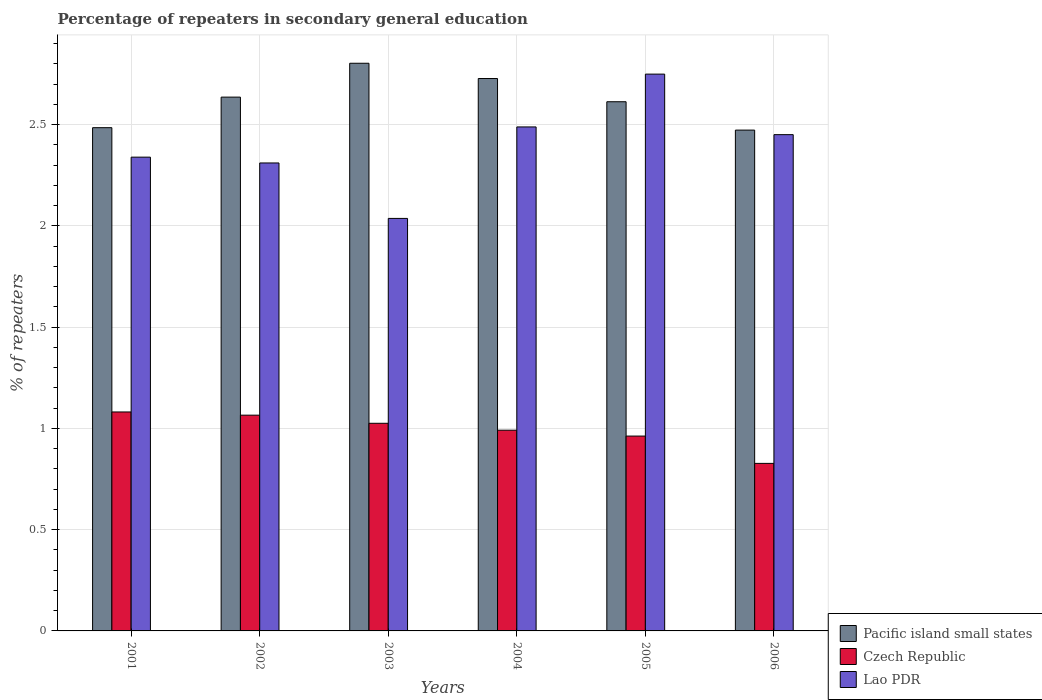Are the number of bars per tick equal to the number of legend labels?
Ensure brevity in your answer.  Yes. How many bars are there on the 3rd tick from the left?
Give a very brief answer. 3. What is the label of the 6th group of bars from the left?
Make the answer very short. 2006. In how many cases, is the number of bars for a given year not equal to the number of legend labels?
Ensure brevity in your answer.  0. What is the percentage of repeaters in secondary general education in Pacific island small states in 2003?
Give a very brief answer. 2.8. Across all years, what is the maximum percentage of repeaters in secondary general education in Lao PDR?
Offer a very short reply. 2.75. Across all years, what is the minimum percentage of repeaters in secondary general education in Lao PDR?
Offer a very short reply. 2.04. In which year was the percentage of repeaters in secondary general education in Lao PDR maximum?
Give a very brief answer. 2005. In which year was the percentage of repeaters in secondary general education in Pacific island small states minimum?
Your answer should be compact. 2006. What is the total percentage of repeaters in secondary general education in Lao PDR in the graph?
Ensure brevity in your answer.  14.37. What is the difference between the percentage of repeaters in secondary general education in Czech Republic in 2004 and that in 2006?
Keep it short and to the point. 0.16. What is the difference between the percentage of repeaters in secondary general education in Pacific island small states in 2005 and the percentage of repeaters in secondary general education in Lao PDR in 2006?
Give a very brief answer. 0.16. What is the average percentage of repeaters in secondary general education in Czech Republic per year?
Your answer should be compact. 0.99. In the year 2006, what is the difference between the percentage of repeaters in secondary general education in Lao PDR and percentage of repeaters in secondary general education in Pacific island small states?
Provide a succinct answer. -0.02. What is the ratio of the percentage of repeaters in secondary general education in Pacific island small states in 2004 to that in 2006?
Offer a very short reply. 1.1. Is the percentage of repeaters in secondary general education in Pacific island small states in 2003 less than that in 2005?
Offer a very short reply. No. Is the difference between the percentage of repeaters in secondary general education in Lao PDR in 2001 and 2003 greater than the difference between the percentage of repeaters in secondary general education in Pacific island small states in 2001 and 2003?
Your answer should be very brief. Yes. What is the difference between the highest and the second highest percentage of repeaters in secondary general education in Czech Republic?
Offer a terse response. 0.02. What is the difference between the highest and the lowest percentage of repeaters in secondary general education in Czech Republic?
Your answer should be compact. 0.25. What does the 3rd bar from the left in 2001 represents?
Your answer should be compact. Lao PDR. What does the 2nd bar from the right in 2003 represents?
Offer a terse response. Czech Republic. How many bars are there?
Offer a terse response. 18. Are the values on the major ticks of Y-axis written in scientific E-notation?
Your response must be concise. No. Does the graph contain any zero values?
Your answer should be very brief. No. Where does the legend appear in the graph?
Your answer should be very brief. Bottom right. How are the legend labels stacked?
Ensure brevity in your answer.  Vertical. What is the title of the graph?
Make the answer very short. Percentage of repeaters in secondary general education. Does "New Caledonia" appear as one of the legend labels in the graph?
Give a very brief answer. No. What is the label or title of the X-axis?
Your answer should be very brief. Years. What is the label or title of the Y-axis?
Your response must be concise. % of repeaters. What is the % of repeaters of Pacific island small states in 2001?
Provide a short and direct response. 2.48. What is the % of repeaters of Czech Republic in 2001?
Make the answer very short. 1.08. What is the % of repeaters in Lao PDR in 2001?
Ensure brevity in your answer.  2.34. What is the % of repeaters in Pacific island small states in 2002?
Offer a very short reply. 2.64. What is the % of repeaters of Czech Republic in 2002?
Provide a succinct answer. 1.07. What is the % of repeaters of Lao PDR in 2002?
Make the answer very short. 2.31. What is the % of repeaters of Pacific island small states in 2003?
Give a very brief answer. 2.8. What is the % of repeaters in Czech Republic in 2003?
Your response must be concise. 1.03. What is the % of repeaters of Lao PDR in 2003?
Provide a short and direct response. 2.04. What is the % of repeaters in Pacific island small states in 2004?
Your response must be concise. 2.73. What is the % of repeaters in Czech Republic in 2004?
Offer a very short reply. 0.99. What is the % of repeaters in Lao PDR in 2004?
Give a very brief answer. 2.49. What is the % of repeaters of Pacific island small states in 2005?
Your response must be concise. 2.61. What is the % of repeaters of Czech Republic in 2005?
Your response must be concise. 0.96. What is the % of repeaters in Lao PDR in 2005?
Provide a succinct answer. 2.75. What is the % of repeaters in Pacific island small states in 2006?
Make the answer very short. 2.47. What is the % of repeaters in Czech Republic in 2006?
Provide a succinct answer. 0.83. What is the % of repeaters in Lao PDR in 2006?
Provide a short and direct response. 2.45. Across all years, what is the maximum % of repeaters of Pacific island small states?
Provide a short and direct response. 2.8. Across all years, what is the maximum % of repeaters in Czech Republic?
Offer a terse response. 1.08. Across all years, what is the maximum % of repeaters of Lao PDR?
Keep it short and to the point. 2.75. Across all years, what is the minimum % of repeaters of Pacific island small states?
Ensure brevity in your answer.  2.47. Across all years, what is the minimum % of repeaters of Czech Republic?
Keep it short and to the point. 0.83. Across all years, what is the minimum % of repeaters of Lao PDR?
Ensure brevity in your answer.  2.04. What is the total % of repeaters of Pacific island small states in the graph?
Your answer should be compact. 15.74. What is the total % of repeaters in Czech Republic in the graph?
Provide a short and direct response. 5.95. What is the total % of repeaters in Lao PDR in the graph?
Keep it short and to the point. 14.37. What is the difference between the % of repeaters in Pacific island small states in 2001 and that in 2002?
Your answer should be compact. -0.15. What is the difference between the % of repeaters in Czech Republic in 2001 and that in 2002?
Offer a very short reply. 0.02. What is the difference between the % of repeaters in Lao PDR in 2001 and that in 2002?
Provide a succinct answer. 0.03. What is the difference between the % of repeaters in Pacific island small states in 2001 and that in 2003?
Provide a short and direct response. -0.32. What is the difference between the % of repeaters of Czech Republic in 2001 and that in 2003?
Keep it short and to the point. 0.06. What is the difference between the % of repeaters in Lao PDR in 2001 and that in 2003?
Provide a short and direct response. 0.3. What is the difference between the % of repeaters of Pacific island small states in 2001 and that in 2004?
Offer a terse response. -0.24. What is the difference between the % of repeaters of Czech Republic in 2001 and that in 2004?
Your answer should be very brief. 0.09. What is the difference between the % of repeaters in Lao PDR in 2001 and that in 2004?
Your answer should be compact. -0.15. What is the difference between the % of repeaters of Pacific island small states in 2001 and that in 2005?
Give a very brief answer. -0.13. What is the difference between the % of repeaters in Czech Republic in 2001 and that in 2005?
Keep it short and to the point. 0.12. What is the difference between the % of repeaters of Lao PDR in 2001 and that in 2005?
Give a very brief answer. -0.41. What is the difference between the % of repeaters in Pacific island small states in 2001 and that in 2006?
Ensure brevity in your answer.  0.01. What is the difference between the % of repeaters in Czech Republic in 2001 and that in 2006?
Ensure brevity in your answer.  0.25. What is the difference between the % of repeaters in Lao PDR in 2001 and that in 2006?
Ensure brevity in your answer.  -0.11. What is the difference between the % of repeaters in Pacific island small states in 2002 and that in 2003?
Your response must be concise. -0.17. What is the difference between the % of repeaters in Czech Republic in 2002 and that in 2003?
Provide a short and direct response. 0.04. What is the difference between the % of repeaters in Lao PDR in 2002 and that in 2003?
Keep it short and to the point. 0.27. What is the difference between the % of repeaters in Pacific island small states in 2002 and that in 2004?
Provide a short and direct response. -0.09. What is the difference between the % of repeaters in Czech Republic in 2002 and that in 2004?
Make the answer very short. 0.07. What is the difference between the % of repeaters of Lao PDR in 2002 and that in 2004?
Keep it short and to the point. -0.18. What is the difference between the % of repeaters of Pacific island small states in 2002 and that in 2005?
Make the answer very short. 0.02. What is the difference between the % of repeaters of Czech Republic in 2002 and that in 2005?
Provide a succinct answer. 0.1. What is the difference between the % of repeaters in Lao PDR in 2002 and that in 2005?
Your answer should be compact. -0.44. What is the difference between the % of repeaters in Pacific island small states in 2002 and that in 2006?
Ensure brevity in your answer.  0.16. What is the difference between the % of repeaters in Czech Republic in 2002 and that in 2006?
Provide a short and direct response. 0.24. What is the difference between the % of repeaters in Lao PDR in 2002 and that in 2006?
Your answer should be very brief. -0.14. What is the difference between the % of repeaters of Pacific island small states in 2003 and that in 2004?
Your answer should be very brief. 0.08. What is the difference between the % of repeaters of Czech Republic in 2003 and that in 2004?
Your response must be concise. 0.03. What is the difference between the % of repeaters of Lao PDR in 2003 and that in 2004?
Your answer should be very brief. -0.45. What is the difference between the % of repeaters in Pacific island small states in 2003 and that in 2005?
Offer a very short reply. 0.19. What is the difference between the % of repeaters of Czech Republic in 2003 and that in 2005?
Keep it short and to the point. 0.06. What is the difference between the % of repeaters in Lao PDR in 2003 and that in 2005?
Provide a short and direct response. -0.71. What is the difference between the % of repeaters in Pacific island small states in 2003 and that in 2006?
Offer a very short reply. 0.33. What is the difference between the % of repeaters in Czech Republic in 2003 and that in 2006?
Your answer should be very brief. 0.2. What is the difference between the % of repeaters in Lao PDR in 2003 and that in 2006?
Ensure brevity in your answer.  -0.41. What is the difference between the % of repeaters in Pacific island small states in 2004 and that in 2005?
Provide a succinct answer. 0.11. What is the difference between the % of repeaters in Czech Republic in 2004 and that in 2005?
Offer a very short reply. 0.03. What is the difference between the % of repeaters of Lao PDR in 2004 and that in 2005?
Give a very brief answer. -0.26. What is the difference between the % of repeaters of Pacific island small states in 2004 and that in 2006?
Keep it short and to the point. 0.25. What is the difference between the % of repeaters of Czech Republic in 2004 and that in 2006?
Make the answer very short. 0.16. What is the difference between the % of repeaters in Lao PDR in 2004 and that in 2006?
Keep it short and to the point. 0.04. What is the difference between the % of repeaters in Pacific island small states in 2005 and that in 2006?
Make the answer very short. 0.14. What is the difference between the % of repeaters of Czech Republic in 2005 and that in 2006?
Your answer should be compact. 0.13. What is the difference between the % of repeaters in Lao PDR in 2005 and that in 2006?
Make the answer very short. 0.3. What is the difference between the % of repeaters in Pacific island small states in 2001 and the % of repeaters in Czech Republic in 2002?
Make the answer very short. 1.42. What is the difference between the % of repeaters of Pacific island small states in 2001 and the % of repeaters of Lao PDR in 2002?
Provide a short and direct response. 0.17. What is the difference between the % of repeaters of Czech Republic in 2001 and the % of repeaters of Lao PDR in 2002?
Ensure brevity in your answer.  -1.23. What is the difference between the % of repeaters in Pacific island small states in 2001 and the % of repeaters in Czech Republic in 2003?
Your answer should be compact. 1.46. What is the difference between the % of repeaters of Pacific island small states in 2001 and the % of repeaters of Lao PDR in 2003?
Provide a short and direct response. 0.45. What is the difference between the % of repeaters in Czech Republic in 2001 and the % of repeaters in Lao PDR in 2003?
Make the answer very short. -0.96. What is the difference between the % of repeaters of Pacific island small states in 2001 and the % of repeaters of Czech Republic in 2004?
Give a very brief answer. 1.49. What is the difference between the % of repeaters in Pacific island small states in 2001 and the % of repeaters in Lao PDR in 2004?
Your answer should be very brief. -0. What is the difference between the % of repeaters of Czech Republic in 2001 and the % of repeaters of Lao PDR in 2004?
Provide a short and direct response. -1.41. What is the difference between the % of repeaters in Pacific island small states in 2001 and the % of repeaters in Czech Republic in 2005?
Offer a very short reply. 1.52. What is the difference between the % of repeaters of Pacific island small states in 2001 and the % of repeaters of Lao PDR in 2005?
Make the answer very short. -0.26. What is the difference between the % of repeaters in Czech Republic in 2001 and the % of repeaters in Lao PDR in 2005?
Provide a succinct answer. -1.67. What is the difference between the % of repeaters in Pacific island small states in 2001 and the % of repeaters in Czech Republic in 2006?
Your answer should be very brief. 1.66. What is the difference between the % of repeaters in Pacific island small states in 2001 and the % of repeaters in Lao PDR in 2006?
Ensure brevity in your answer.  0.03. What is the difference between the % of repeaters of Czech Republic in 2001 and the % of repeaters of Lao PDR in 2006?
Provide a succinct answer. -1.37. What is the difference between the % of repeaters of Pacific island small states in 2002 and the % of repeaters of Czech Republic in 2003?
Your answer should be compact. 1.61. What is the difference between the % of repeaters in Pacific island small states in 2002 and the % of repeaters in Lao PDR in 2003?
Ensure brevity in your answer.  0.6. What is the difference between the % of repeaters of Czech Republic in 2002 and the % of repeaters of Lao PDR in 2003?
Your answer should be compact. -0.97. What is the difference between the % of repeaters in Pacific island small states in 2002 and the % of repeaters in Czech Republic in 2004?
Ensure brevity in your answer.  1.64. What is the difference between the % of repeaters in Pacific island small states in 2002 and the % of repeaters in Lao PDR in 2004?
Your response must be concise. 0.15. What is the difference between the % of repeaters in Czech Republic in 2002 and the % of repeaters in Lao PDR in 2004?
Make the answer very short. -1.42. What is the difference between the % of repeaters of Pacific island small states in 2002 and the % of repeaters of Czech Republic in 2005?
Offer a very short reply. 1.67. What is the difference between the % of repeaters in Pacific island small states in 2002 and the % of repeaters in Lao PDR in 2005?
Ensure brevity in your answer.  -0.11. What is the difference between the % of repeaters in Czech Republic in 2002 and the % of repeaters in Lao PDR in 2005?
Your answer should be very brief. -1.68. What is the difference between the % of repeaters in Pacific island small states in 2002 and the % of repeaters in Czech Republic in 2006?
Ensure brevity in your answer.  1.81. What is the difference between the % of repeaters of Pacific island small states in 2002 and the % of repeaters of Lao PDR in 2006?
Your answer should be very brief. 0.19. What is the difference between the % of repeaters in Czech Republic in 2002 and the % of repeaters in Lao PDR in 2006?
Your response must be concise. -1.39. What is the difference between the % of repeaters of Pacific island small states in 2003 and the % of repeaters of Czech Republic in 2004?
Keep it short and to the point. 1.81. What is the difference between the % of repeaters in Pacific island small states in 2003 and the % of repeaters in Lao PDR in 2004?
Give a very brief answer. 0.31. What is the difference between the % of repeaters in Czech Republic in 2003 and the % of repeaters in Lao PDR in 2004?
Your answer should be compact. -1.46. What is the difference between the % of repeaters in Pacific island small states in 2003 and the % of repeaters in Czech Republic in 2005?
Offer a very short reply. 1.84. What is the difference between the % of repeaters in Pacific island small states in 2003 and the % of repeaters in Lao PDR in 2005?
Offer a terse response. 0.05. What is the difference between the % of repeaters of Czech Republic in 2003 and the % of repeaters of Lao PDR in 2005?
Offer a terse response. -1.72. What is the difference between the % of repeaters of Pacific island small states in 2003 and the % of repeaters of Czech Republic in 2006?
Make the answer very short. 1.98. What is the difference between the % of repeaters of Pacific island small states in 2003 and the % of repeaters of Lao PDR in 2006?
Provide a short and direct response. 0.35. What is the difference between the % of repeaters of Czech Republic in 2003 and the % of repeaters of Lao PDR in 2006?
Ensure brevity in your answer.  -1.43. What is the difference between the % of repeaters of Pacific island small states in 2004 and the % of repeaters of Czech Republic in 2005?
Keep it short and to the point. 1.77. What is the difference between the % of repeaters of Pacific island small states in 2004 and the % of repeaters of Lao PDR in 2005?
Offer a terse response. -0.02. What is the difference between the % of repeaters in Czech Republic in 2004 and the % of repeaters in Lao PDR in 2005?
Your response must be concise. -1.76. What is the difference between the % of repeaters of Pacific island small states in 2004 and the % of repeaters of Czech Republic in 2006?
Keep it short and to the point. 1.9. What is the difference between the % of repeaters in Pacific island small states in 2004 and the % of repeaters in Lao PDR in 2006?
Ensure brevity in your answer.  0.28. What is the difference between the % of repeaters in Czech Republic in 2004 and the % of repeaters in Lao PDR in 2006?
Offer a very short reply. -1.46. What is the difference between the % of repeaters of Pacific island small states in 2005 and the % of repeaters of Czech Republic in 2006?
Offer a terse response. 1.79. What is the difference between the % of repeaters in Pacific island small states in 2005 and the % of repeaters in Lao PDR in 2006?
Your answer should be very brief. 0.16. What is the difference between the % of repeaters in Czech Republic in 2005 and the % of repeaters in Lao PDR in 2006?
Your answer should be very brief. -1.49. What is the average % of repeaters of Pacific island small states per year?
Your response must be concise. 2.62. What is the average % of repeaters in Czech Republic per year?
Give a very brief answer. 0.99. What is the average % of repeaters of Lao PDR per year?
Provide a short and direct response. 2.4. In the year 2001, what is the difference between the % of repeaters of Pacific island small states and % of repeaters of Czech Republic?
Offer a very short reply. 1.4. In the year 2001, what is the difference between the % of repeaters in Pacific island small states and % of repeaters in Lao PDR?
Ensure brevity in your answer.  0.15. In the year 2001, what is the difference between the % of repeaters of Czech Republic and % of repeaters of Lao PDR?
Your answer should be very brief. -1.26. In the year 2002, what is the difference between the % of repeaters in Pacific island small states and % of repeaters in Czech Republic?
Provide a succinct answer. 1.57. In the year 2002, what is the difference between the % of repeaters in Pacific island small states and % of repeaters in Lao PDR?
Make the answer very short. 0.33. In the year 2002, what is the difference between the % of repeaters in Czech Republic and % of repeaters in Lao PDR?
Your response must be concise. -1.25. In the year 2003, what is the difference between the % of repeaters in Pacific island small states and % of repeaters in Czech Republic?
Make the answer very short. 1.78. In the year 2003, what is the difference between the % of repeaters in Pacific island small states and % of repeaters in Lao PDR?
Give a very brief answer. 0.77. In the year 2003, what is the difference between the % of repeaters in Czech Republic and % of repeaters in Lao PDR?
Give a very brief answer. -1.01. In the year 2004, what is the difference between the % of repeaters of Pacific island small states and % of repeaters of Czech Republic?
Your answer should be compact. 1.74. In the year 2004, what is the difference between the % of repeaters of Pacific island small states and % of repeaters of Lao PDR?
Make the answer very short. 0.24. In the year 2004, what is the difference between the % of repeaters of Czech Republic and % of repeaters of Lao PDR?
Your response must be concise. -1.5. In the year 2005, what is the difference between the % of repeaters in Pacific island small states and % of repeaters in Czech Republic?
Offer a very short reply. 1.65. In the year 2005, what is the difference between the % of repeaters of Pacific island small states and % of repeaters of Lao PDR?
Your response must be concise. -0.14. In the year 2005, what is the difference between the % of repeaters of Czech Republic and % of repeaters of Lao PDR?
Make the answer very short. -1.79. In the year 2006, what is the difference between the % of repeaters in Pacific island small states and % of repeaters in Czech Republic?
Give a very brief answer. 1.65. In the year 2006, what is the difference between the % of repeaters in Pacific island small states and % of repeaters in Lao PDR?
Offer a terse response. 0.02. In the year 2006, what is the difference between the % of repeaters in Czech Republic and % of repeaters in Lao PDR?
Keep it short and to the point. -1.62. What is the ratio of the % of repeaters of Pacific island small states in 2001 to that in 2002?
Provide a succinct answer. 0.94. What is the ratio of the % of repeaters in Czech Republic in 2001 to that in 2002?
Provide a succinct answer. 1.01. What is the ratio of the % of repeaters in Lao PDR in 2001 to that in 2002?
Ensure brevity in your answer.  1.01. What is the ratio of the % of repeaters of Pacific island small states in 2001 to that in 2003?
Provide a succinct answer. 0.89. What is the ratio of the % of repeaters in Czech Republic in 2001 to that in 2003?
Offer a terse response. 1.05. What is the ratio of the % of repeaters of Lao PDR in 2001 to that in 2003?
Provide a succinct answer. 1.15. What is the ratio of the % of repeaters in Pacific island small states in 2001 to that in 2004?
Provide a short and direct response. 0.91. What is the ratio of the % of repeaters in Czech Republic in 2001 to that in 2004?
Ensure brevity in your answer.  1.09. What is the ratio of the % of repeaters in Lao PDR in 2001 to that in 2004?
Offer a terse response. 0.94. What is the ratio of the % of repeaters of Pacific island small states in 2001 to that in 2005?
Provide a succinct answer. 0.95. What is the ratio of the % of repeaters of Czech Republic in 2001 to that in 2005?
Your answer should be compact. 1.12. What is the ratio of the % of repeaters in Lao PDR in 2001 to that in 2005?
Your response must be concise. 0.85. What is the ratio of the % of repeaters of Pacific island small states in 2001 to that in 2006?
Your answer should be very brief. 1. What is the ratio of the % of repeaters of Czech Republic in 2001 to that in 2006?
Keep it short and to the point. 1.31. What is the ratio of the % of repeaters of Lao PDR in 2001 to that in 2006?
Your answer should be very brief. 0.95. What is the ratio of the % of repeaters of Pacific island small states in 2002 to that in 2003?
Give a very brief answer. 0.94. What is the ratio of the % of repeaters of Czech Republic in 2002 to that in 2003?
Offer a very short reply. 1.04. What is the ratio of the % of repeaters of Lao PDR in 2002 to that in 2003?
Provide a succinct answer. 1.13. What is the ratio of the % of repeaters in Pacific island small states in 2002 to that in 2004?
Provide a succinct answer. 0.97. What is the ratio of the % of repeaters of Czech Republic in 2002 to that in 2004?
Provide a short and direct response. 1.07. What is the ratio of the % of repeaters in Lao PDR in 2002 to that in 2004?
Your response must be concise. 0.93. What is the ratio of the % of repeaters in Pacific island small states in 2002 to that in 2005?
Provide a short and direct response. 1.01. What is the ratio of the % of repeaters in Czech Republic in 2002 to that in 2005?
Offer a very short reply. 1.11. What is the ratio of the % of repeaters of Lao PDR in 2002 to that in 2005?
Offer a terse response. 0.84. What is the ratio of the % of repeaters of Pacific island small states in 2002 to that in 2006?
Offer a terse response. 1.07. What is the ratio of the % of repeaters of Czech Republic in 2002 to that in 2006?
Keep it short and to the point. 1.29. What is the ratio of the % of repeaters in Lao PDR in 2002 to that in 2006?
Your answer should be compact. 0.94. What is the ratio of the % of repeaters in Pacific island small states in 2003 to that in 2004?
Keep it short and to the point. 1.03. What is the ratio of the % of repeaters in Czech Republic in 2003 to that in 2004?
Your answer should be very brief. 1.03. What is the ratio of the % of repeaters in Lao PDR in 2003 to that in 2004?
Offer a very short reply. 0.82. What is the ratio of the % of repeaters of Pacific island small states in 2003 to that in 2005?
Make the answer very short. 1.07. What is the ratio of the % of repeaters in Czech Republic in 2003 to that in 2005?
Provide a succinct answer. 1.07. What is the ratio of the % of repeaters in Lao PDR in 2003 to that in 2005?
Ensure brevity in your answer.  0.74. What is the ratio of the % of repeaters of Pacific island small states in 2003 to that in 2006?
Keep it short and to the point. 1.13. What is the ratio of the % of repeaters in Czech Republic in 2003 to that in 2006?
Provide a succinct answer. 1.24. What is the ratio of the % of repeaters of Lao PDR in 2003 to that in 2006?
Make the answer very short. 0.83. What is the ratio of the % of repeaters in Pacific island small states in 2004 to that in 2005?
Provide a short and direct response. 1.04. What is the ratio of the % of repeaters of Czech Republic in 2004 to that in 2005?
Your response must be concise. 1.03. What is the ratio of the % of repeaters of Lao PDR in 2004 to that in 2005?
Give a very brief answer. 0.91. What is the ratio of the % of repeaters of Pacific island small states in 2004 to that in 2006?
Your response must be concise. 1.1. What is the ratio of the % of repeaters of Czech Republic in 2004 to that in 2006?
Provide a short and direct response. 1.2. What is the ratio of the % of repeaters of Lao PDR in 2004 to that in 2006?
Offer a terse response. 1.02. What is the ratio of the % of repeaters in Pacific island small states in 2005 to that in 2006?
Your answer should be compact. 1.06. What is the ratio of the % of repeaters in Czech Republic in 2005 to that in 2006?
Provide a succinct answer. 1.16. What is the ratio of the % of repeaters in Lao PDR in 2005 to that in 2006?
Your answer should be compact. 1.12. What is the difference between the highest and the second highest % of repeaters of Pacific island small states?
Your response must be concise. 0.08. What is the difference between the highest and the second highest % of repeaters in Czech Republic?
Your answer should be very brief. 0.02. What is the difference between the highest and the second highest % of repeaters in Lao PDR?
Ensure brevity in your answer.  0.26. What is the difference between the highest and the lowest % of repeaters in Pacific island small states?
Your response must be concise. 0.33. What is the difference between the highest and the lowest % of repeaters of Czech Republic?
Your response must be concise. 0.25. What is the difference between the highest and the lowest % of repeaters in Lao PDR?
Keep it short and to the point. 0.71. 